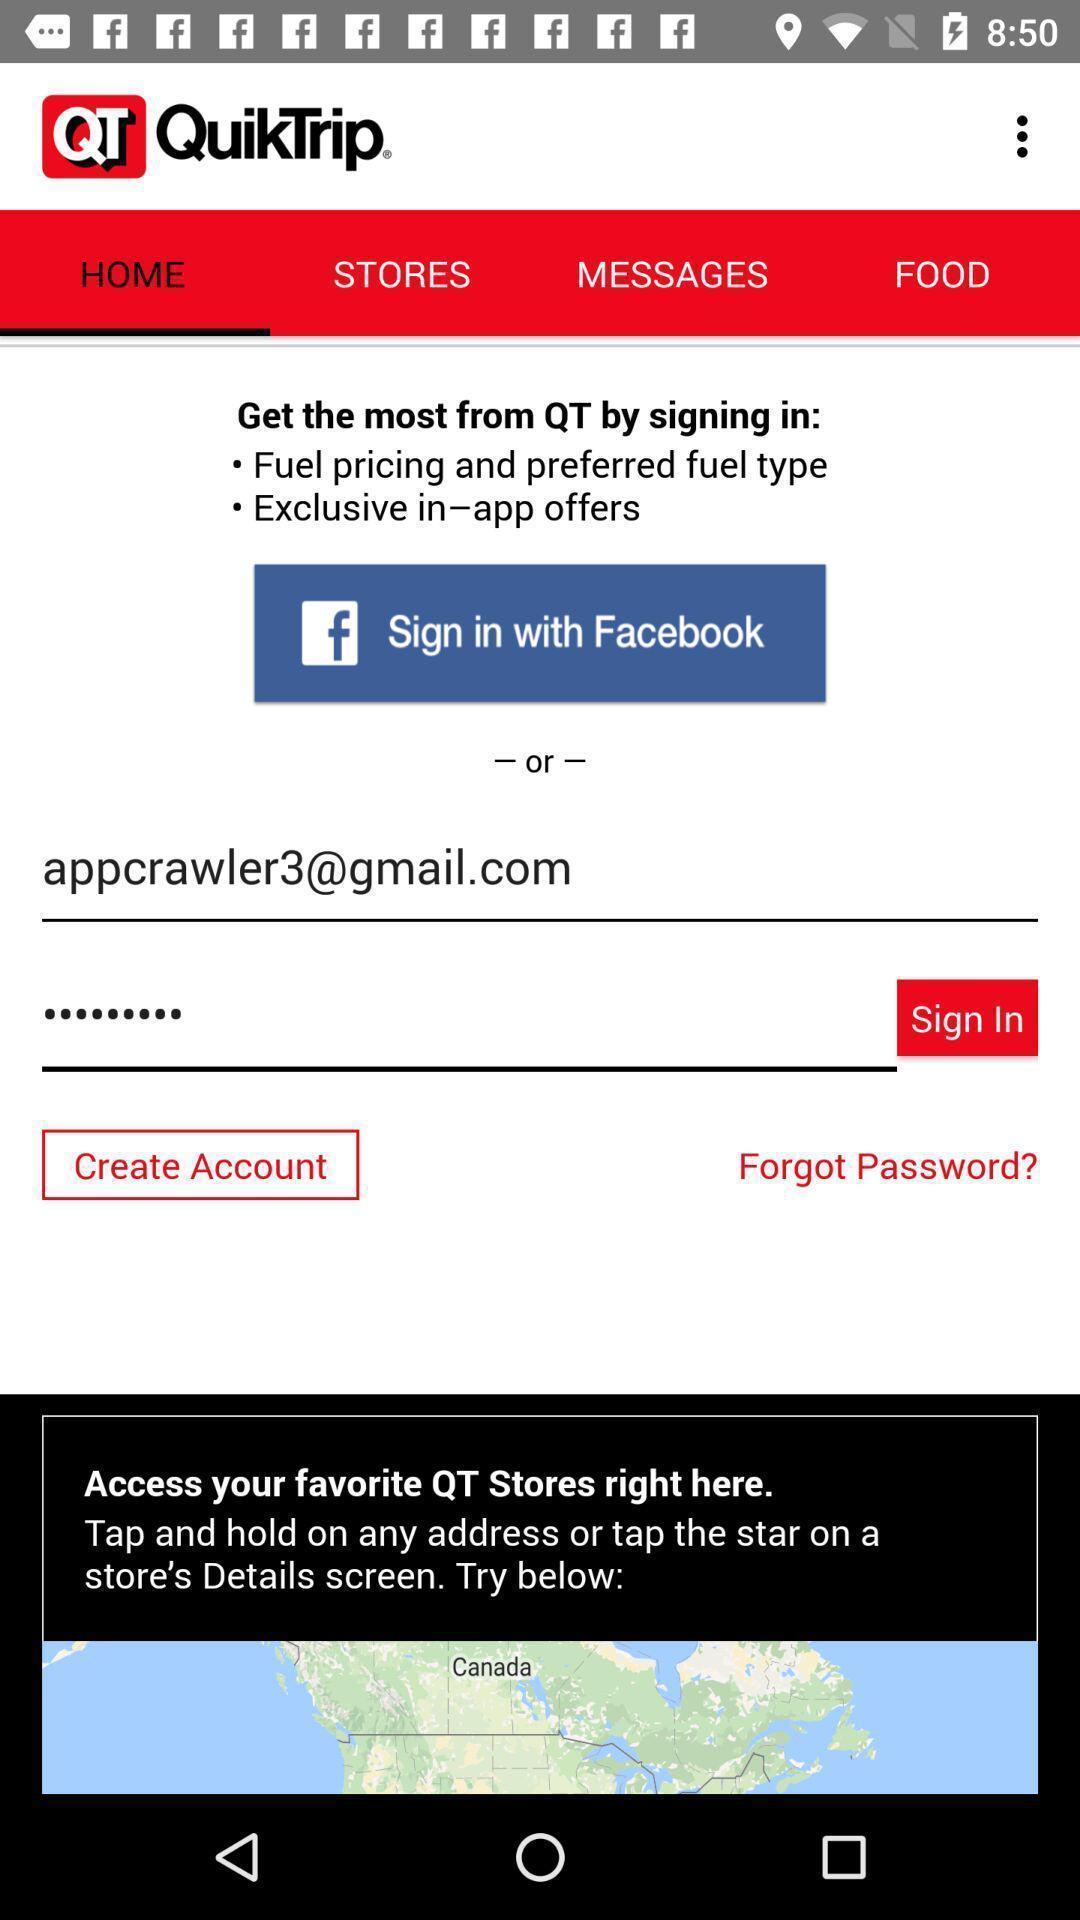Describe this image in words. Sign in page. 